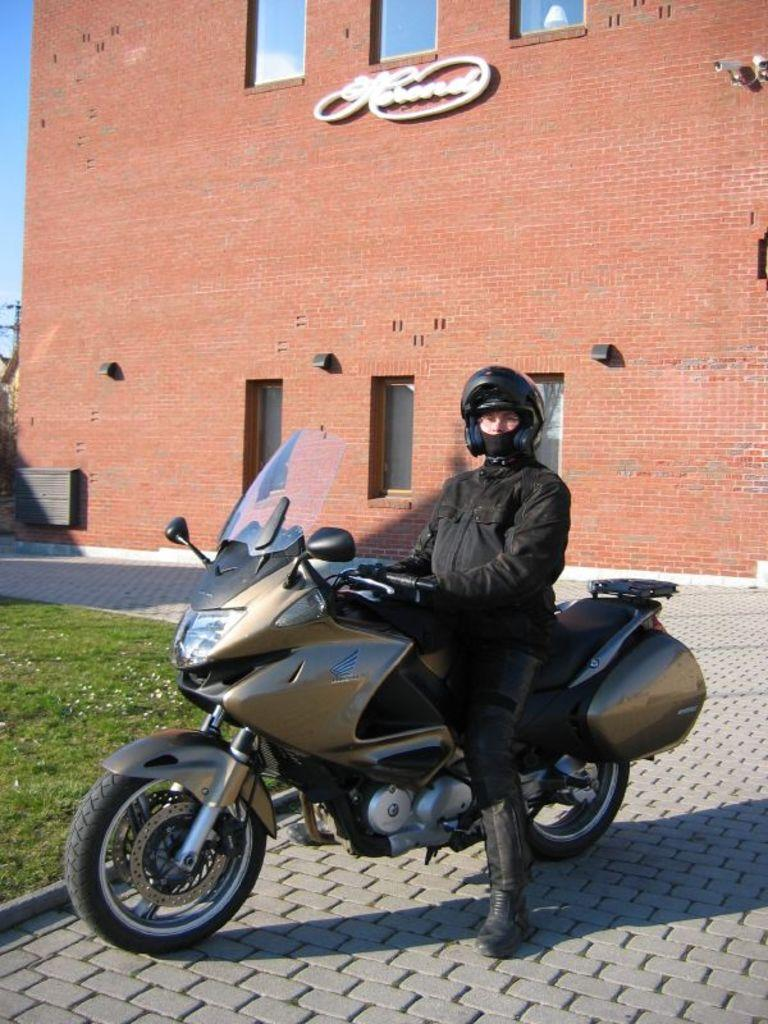What is the man in the image doing? The man is sitting on a motorbike in the image. Where is the motorbike located? The motorbike is in a street. What type of vegetation can be seen in the image? There is grass and flowers visible in the image. What can be seen in the background of the image? There are buildings, the sky, a CCTV camera, and a pole in the background of the image. What type of history can be learned from the tub in the image? There is no tub present in the image, so no history can be learned from it. What type of shade is provided by the flowers in the image? The flowers in the image do not provide shade; they are simply visible vegetation. 